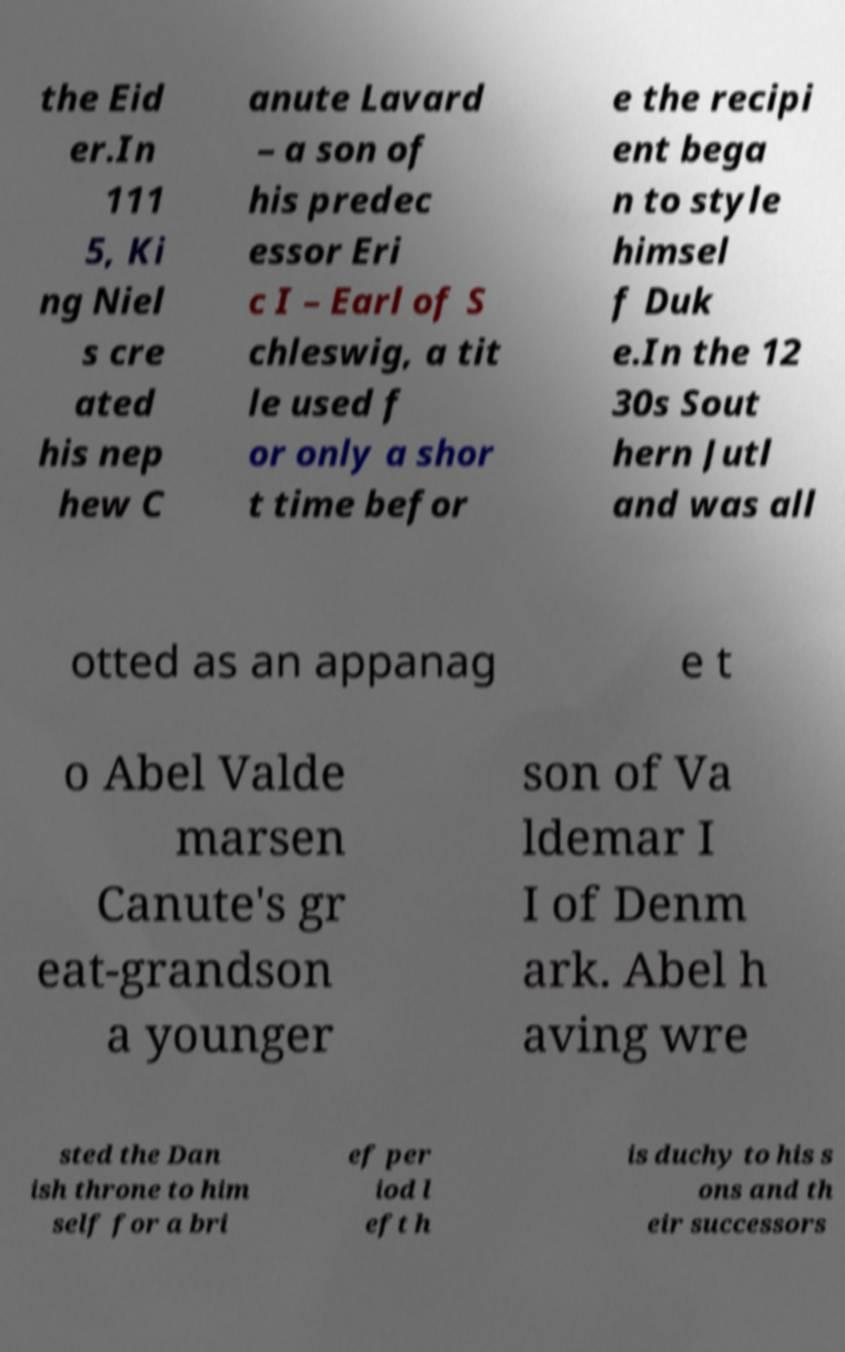Could you extract and type out the text from this image? the Eid er.In 111 5, Ki ng Niel s cre ated his nep hew C anute Lavard – a son of his predec essor Eri c I – Earl of S chleswig, a tit le used f or only a shor t time befor e the recipi ent bega n to style himsel f Duk e.In the 12 30s Sout hern Jutl and was all otted as an appanag e t o Abel Valde marsen Canute's gr eat-grandson a younger son of Va ldemar I I of Denm ark. Abel h aving wre sted the Dan ish throne to him self for a bri ef per iod l eft h is duchy to his s ons and th eir successors 